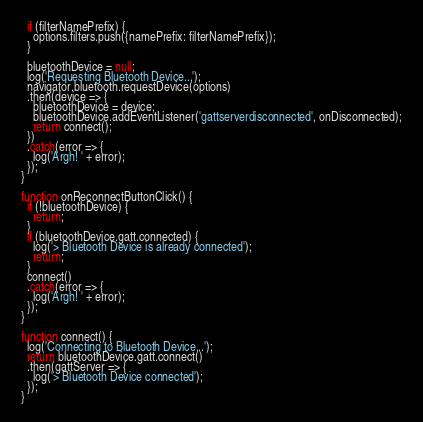<code> <loc_0><loc_0><loc_500><loc_500><_JavaScript_>  if (filterNamePrefix) {
    options.filters.push({namePrefix: filterNamePrefix});
  }

  bluetoothDevice = null;
  log('Requesting Bluetooth Device...');
  navigator.bluetooth.requestDevice(options)
  .then(device => {
    bluetoothDevice = device;
    bluetoothDevice.addEventListener('gattserverdisconnected', onDisconnected);
    return connect();
  })
  .catch(error => {
    log('Argh! ' + error);
  });
}

function onReconnectButtonClick() {
  if (!bluetoothDevice) {
    return;
  }
  if (bluetoothDevice.gatt.connected) {
    log('> Bluetooth Device is already connected');
    return;
  }
  connect()
  .catch(error => {
    log('Argh! ' + error);
  });
}

function connect() {
  log('Connecting to Bluetooth Device...');
  return bluetoothDevice.gatt.connect()
  .then(gattServer => {
    log('> Bluetooth Device connected');
  });
}
</code> 